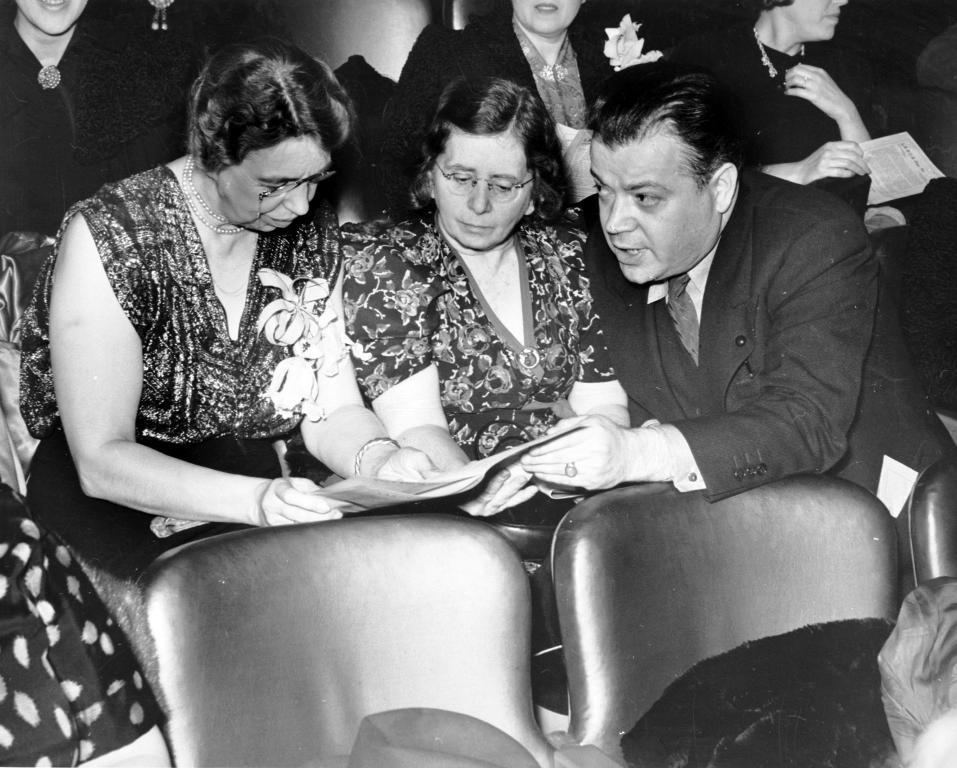What is the color scheme of the image? The image is black and white. What can be seen in the image? There are people in the image. What are the people doing in the image? The people are sitting on chairs. Can you see a rose on the table in the image? There is no rose present in the image. What type of cheese is being served to the people in the image? There is no cheese present in the image. 